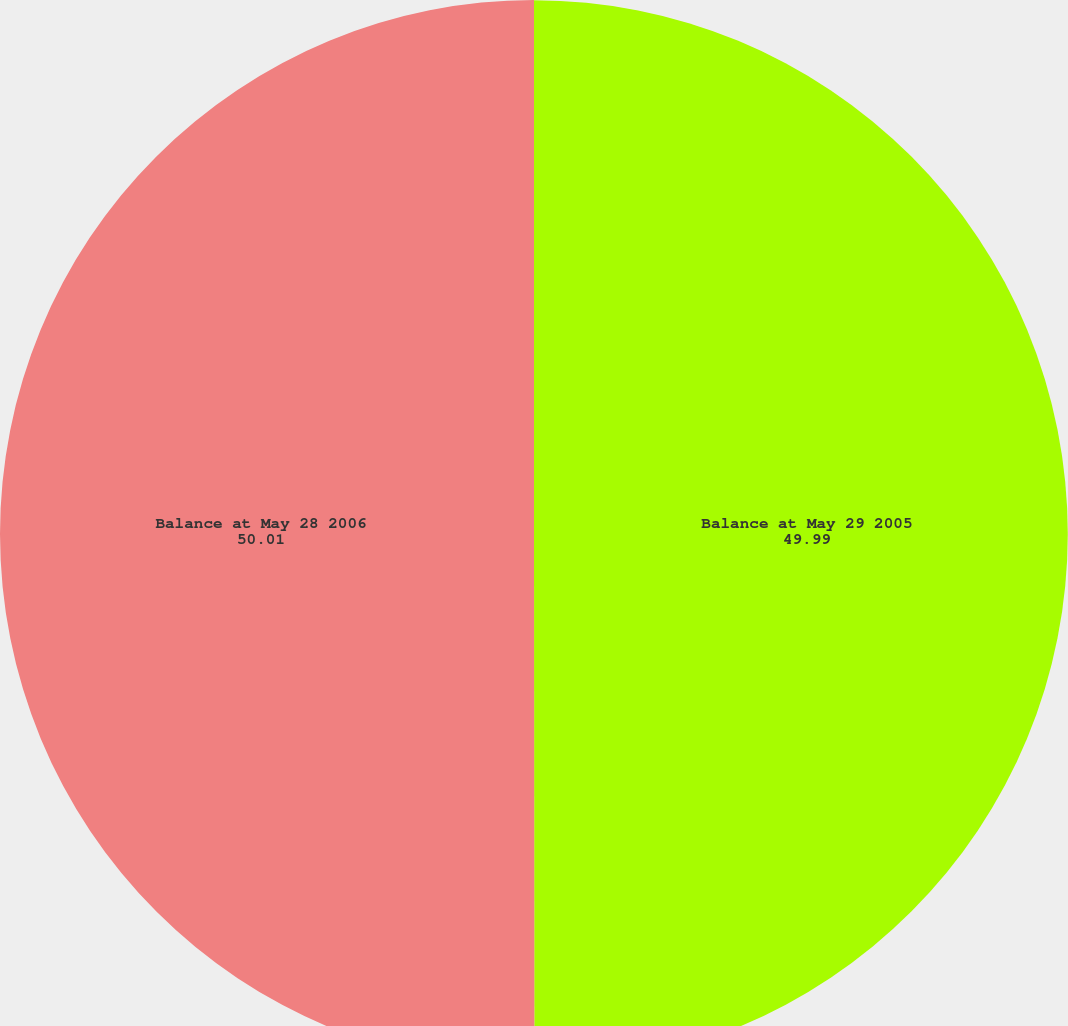<chart> <loc_0><loc_0><loc_500><loc_500><pie_chart><fcel>Balance at May 29 2005<fcel>Balance at May 28 2006<nl><fcel>49.99%<fcel>50.01%<nl></chart> 